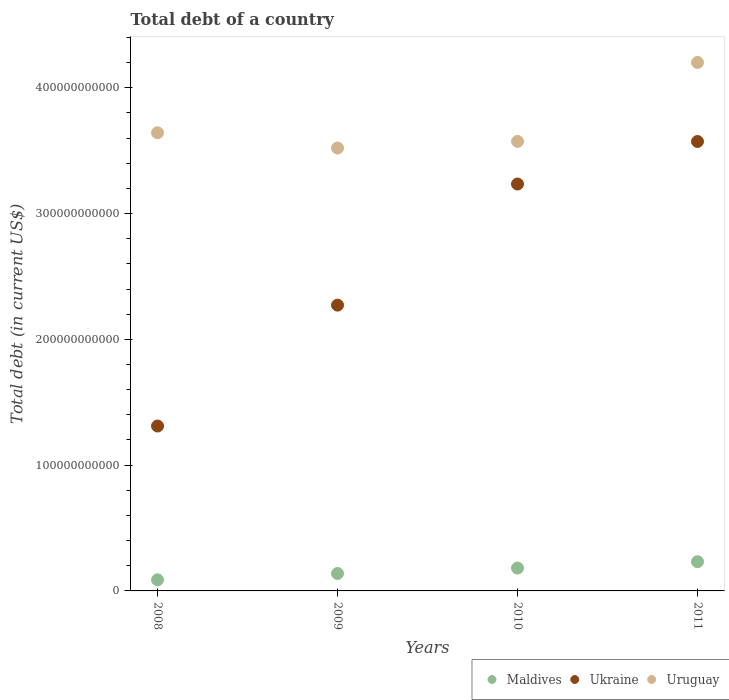How many different coloured dotlines are there?
Offer a very short reply. 3. What is the debt in Uruguay in 2009?
Offer a terse response. 3.52e+11. Across all years, what is the maximum debt in Maldives?
Keep it short and to the point. 2.32e+1. Across all years, what is the minimum debt in Maldives?
Give a very brief answer. 8.82e+09. In which year was the debt in Uruguay maximum?
Make the answer very short. 2011. What is the total debt in Maldives in the graph?
Your answer should be compact. 6.41e+1. What is the difference between the debt in Uruguay in 2009 and that in 2011?
Give a very brief answer. -6.80e+1. What is the difference between the debt in Ukraine in 2008 and the debt in Maldives in 2009?
Your answer should be very brief. 1.17e+11. What is the average debt in Ukraine per year?
Provide a short and direct response. 2.60e+11. In the year 2010, what is the difference between the debt in Ukraine and debt in Maldives?
Your response must be concise. 3.05e+11. What is the ratio of the debt in Maldives in 2008 to that in 2010?
Offer a terse response. 0.49. What is the difference between the highest and the second highest debt in Maldives?
Offer a very short reply. 5.03e+09. What is the difference between the highest and the lowest debt in Maldives?
Make the answer very short. 1.44e+1. In how many years, is the debt in Ukraine greater than the average debt in Ukraine taken over all years?
Keep it short and to the point. 2. Is it the case that in every year, the sum of the debt in Ukraine and debt in Uruguay  is greater than the debt in Maldives?
Your response must be concise. Yes. Does the debt in Uruguay monotonically increase over the years?
Make the answer very short. No. How many dotlines are there?
Your answer should be compact. 3. How many years are there in the graph?
Keep it short and to the point. 4. What is the difference between two consecutive major ticks on the Y-axis?
Offer a very short reply. 1.00e+11. Are the values on the major ticks of Y-axis written in scientific E-notation?
Provide a short and direct response. No. Does the graph contain any zero values?
Offer a very short reply. No. How are the legend labels stacked?
Your answer should be very brief. Horizontal. What is the title of the graph?
Your response must be concise. Total debt of a country. Does "Kiribati" appear as one of the legend labels in the graph?
Offer a terse response. No. What is the label or title of the X-axis?
Give a very brief answer. Years. What is the label or title of the Y-axis?
Your response must be concise. Total debt (in current US$). What is the Total debt (in current US$) of Maldives in 2008?
Provide a short and direct response. 8.82e+09. What is the Total debt (in current US$) in Ukraine in 2008?
Give a very brief answer. 1.31e+11. What is the Total debt (in current US$) in Uruguay in 2008?
Give a very brief answer. 3.64e+11. What is the Total debt (in current US$) of Maldives in 2009?
Your answer should be very brief. 1.39e+1. What is the Total debt (in current US$) of Ukraine in 2009?
Offer a very short reply. 2.27e+11. What is the Total debt (in current US$) in Uruguay in 2009?
Your response must be concise. 3.52e+11. What is the Total debt (in current US$) in Maldives in 2010?
Provide a short and direct response. 1.82e+1. What is the Total debt (in current US$) of Ukraine in 2010?
Your answer should be compact. 3.23e+11. What is the Total debt (in current US$) in Uruguay in 2010?
Keep it short and to the point. 3.57e+11. What is the Total debt (in current US$) in Maldives in 2011?
Provide a succinct answer. 2.32e+1. What is the Total debt (in current US$) in Ukraine in 2011?
Keep it short and to the point. 3.57e+11. What is the Total debt (in current US$) of Uruguay in 2011?
Your answer should be very brief. 4.20e+11. Across all years, what is the maximum Total debt (in current US$) of Maldives?
Provide a short and direct response. 2.32e+1. Across all years, what is the maximum Total debt (in current US$) in Ukraine?
Your response must be concise. 3.57e+11. Across all years, what is the maximum Total debt (in current US$) of Uruguay?
Your answer should be compact. 4.20e+11. Across all years, what is the minimum Total debt (in current US$) in Maldives?
Provide a short and direct response. 8.82e+09. Across all years, what is the minimum Total debt (in current US$) of Ukraine?
Offer a terse response. 1.31e+11. Across all years, what is the minimum Total debt (in current US$) in Uruguay?
Offer a very short reply. 3.52e+11. What is the total Total debt (in current US$) in Maldives in the graph?
Your answer should be compact. 6.41e+1. What is the total Total debt (in current US$) in Ukraine in the graph?
Provide a short and direct response. 1.04e+12. What is the total Total debt (in current US$) in Uruguay in the graph?
Offer a very short reply. 1.49e+12. What is the difference between the Total debt (in current US$) in Maldives in 2008 and that in 2009?
Ensure brevity in your answer.  -5.04e+09. What is the difference between the Total debt (in current US$) in Ukraine in 2008 and that in 2009?
Keep it short and to the point. -9.61e+1. What is the difference between the Total debt (in current US$) in Uruguay in 2008 and that in 2009?
Provide a short and direct response. 1.21e+1. What is the difference between the Total debt (in current US$) of Maldives in 2008 and that in 2010?
Make the answer very short. -9.36e+09. What is the difference between the Total debt (in current US$) of Ukraine in 2008 and that in 2010?
Your answer should be compact. -1.92e+11. What is the difference between the Total debt (in current US$) in Uruguay in 2008 and that in 2010?
Keep it short and to the point. 6.86e+09. What is the difference between the Total debt (in current US$) in Maldives in 2008 and that in 2011?
Make the answer very short. -1.44e+1. What is the difference between the Total debt (in current US$) of Ukraine in 2008 and that in 2011?
Keep it short and to the point. -2.26e+11. What is the difference between the Total debt (in current US$) in Uruguay in 2008 and that in 2011?
Your answer should be very brief. -5.59e+1. What is the difference between the Total debt (in current US$) in Maldives in 2009 and that in 2010?
Give a very brief answer. -4.32e+09. What is the difference between the Total debt (in current US$) of Ukraine in 2009 and that in 2010?
Your answer should be compact. -9.63e+1. What is the difference between the Total debt (in current US$) in Uruguay in 2009 and that in 2010?
Provide a succinct answer. -5.28e+09. What is the difference between the Total debt (in current US$) in Maldives in 2009 and that in 2011?
Provide a short and direct response. -9.34e+09. What is the difference between the Total debt (in current US$) in Ukraine in 2009 and that in 2011?
Provide a short and direct response. -1.30e+11. What is the difference between the Total debt (in current US$) of Uruguay in 2009 and that in 2011?
Your answer should be very brief. -6.80e+1. What is the difference between the Total debt (in current US$) of Maldives in 2010 and that in 2011?
Your answer should be compact. -5.03e+09. What is the difference between the Total debt (in current US$) in Ukraine in 2010 and that in 2011?
Make the answer very short. -3.38e+1. What is the difference between the Total debt (in current US$) in Uruguay in 2010 and that in 2011?
Your answer should be compact. -6.28e+1. What is the difference between the Total debt (in current US$) of Maldives in 2008 and the Total debt (in current US$) of Ukraine in 2009?
Your response must be concise. -2.18e+11. What is the difference between the Total debt (in current US$) in Maldives in 2008 and the Total debt (in current US$) in Uruguay in 2009?
Provide a short and direct response. -3.43e+11. What is the difference between the Total debt (in current US$) of Ukraine in 2008 and the Total debt (in current US$) of Uruguay in 2009?
Offer a very short reply. -2.21e+11. What is the difference between the Total debt (in current US$) in Maldives in 2008 and the Total debt (in current US$) in Ukraine in 2010?
Provide a succinct answer. -3.15e+11. What is the difference between the Total debt (in current US$) in Maldives in 2008 and the Total debt (in current US$) in Uruguay in 2010?
Your answer should be compact. -3.49e+11. What is the difference between the Total debt (in current US$) of Ukraine in 2008 and the Total debt (in current US$) of Uruguay in 2010?
Offer a terse response. -2.26e+11. What is the difference between the Total debt (in current US$) of Maldives in 2008 and the Total debt (in current US$) of Ukraine in 2011?
Your response must be concise. -3.48e+11. What is the difference between the Total debt (in current US$) in Maldives in 2008 and the Total debt (in current US$) in Uruguay in 2011?
Keep it short and to the point. -4.11e+11. What is the difference between the Total debt (in current US$) in Ukraine in 2008 and the Total debt (in current US$) in Uruguay in 2011?
Make the answer very short. -2.89e+11. What is the difference between the Total debt (in current US$) in Maldives in 2009 and the Total debt (in current US$) in Ukraine in 2010?
Make the answer very short. -3.10e+11. What is the difference between the Total debt (in current US$) in Maldives in 2009 and the Total debt (in current US$) in Uruguay in 2010?
Make the answer very short. -3.43e+11. What is the difference between the Total debt (in current US$) of Ukraine in 2009 and the Total debt (in current US$) of Uruguay in 2010?
Offer a terse response. -1.30e+11. What is the difference between the Total debt (in current US$) in Maldives in 2009 and the Total debt (in current US$) in Ukraine in 2011?
Offer a very short reply. -3.43e+11. What is the difference between the Total debt (in current US$) in Maldives in 2009 and the Total debt (in current US$) in Uruguay in 2011?
Offer a very short reply. -4.06e+11. What is the difference between the Total debt (in current US$) of Ukraine in 2009 and the Total debt (in current US$) of Uruguay in 2011?
Your answer should be compact. -1.93e+11. What is the difference between the Total debt (in current US$) of Maldives in 2010 and the Total debt (in current US$) of Ukraine in 2011?
Your answer should be compact. -3.39e+11. What is the difference between the Total debt (in current US$) of Maldives in 2010 and the Total debt (in current US$) of Uruguay in 2011?
Give a very brief answer. -4.02e+11. What is the difference between the Total debt (in current US$) in Ukraine in 2010 and the Total debt (in current US$) in Uruguay in 2011?
Offer a terse response. -9.66e+1. What is the average Total debt (in current US$) of Maldives per year?
Ensure brevity in your answer.  1.60e+1. What is the average Total debt (in current US$) of Ukraine per year?
Offer a very short reply. 2.60e+11. What is the average Total debt (in current US$) of Uruguay per year?
Provide a succinct answer. 3.73e+11. In the year 2008, what is the difference between the Total debt (in current US$) in Maldives and Total debt (in current US$) in Ukraine?
Make the answer very short. -1.22e+11. In the year 2008, what is the difference between the Total debt (in current US$) in Maldives and Total debt (in current US$) in Uruguay?
Provide a succinct answer. -3.55e+11. In the year 2008, what is the difference between the Total debt (in current US$) of Ukraine and Total debt (in current US$) of Uruguay?
Your answer should be very brief. -2.33e+11. In the year 2009, what is the difference between the Total debt (in current US$) in Maldives and Total debt (in current US$) in Ukraine?
Offer a very short reply. -2.13e+11. In the year 2009, what is the difference between the Total debt (in current US$) of Maldives and Total debt (in current US$) of Uruguay?
Provide a short and direct response. -3.38e+11. In the year 2009, what is the difference between the Total debt (in current US$) in Ukraine and Total debt (in current US$) in Uruguay?
Make the answer very short. -1.25e+11. In the year 2010, what is the difference between the Total debt (in current US$) in Maldives and Total debt (in current US$) in Ukraine?
Your response must be concise. -3.05e+11. In the year 2010, what is the difference between the Total debt (in current US$) of Maldives and Total debt (in current US$) of Uruguay?
Give a very brief answer. -3.39e+11. In the year 2010, what is the difference between the Total debt (in current US$) in Ukraine and Total debt (in current US$) in Uruguay?
Make the answer very short. -3.39e+1. In the year 2011, what is the difference between the Total debt (in current US$) of Maldives and Total debt (in current US$) of Ukraine?
Give a very brief answer. -3.34e+11. In the year 2011, what is the difference between the Total debt (in current US$) of Maldives and Total debt (in current US$) of Uruguay?
Ensure brevity in your answer.  -3.97e+11. In the year 2011, what is the difference between the Total debt (in current US$) in Ukraine and Total debt (in current US$) in Uruguay?
Keep it short and to the point. -6.28e+1. What is the ratio of the Total debt (in current US$) of Maldives in 2008 to that in 2009?
Offer a terse response. 0.64. What is the ratio of the Total debt (in current US$) of Ukraine in 2008 to that in 2009?
Offer a terse response. 0.58. What is the ratio of the Total debt (in current US$) of Uruguay in 2008 to that in 2009?
Your answer should be very brief. 1.03. What is the ratio of the Total debt (in current US$) of Maldives in 2008 to that in 2010?
Make the answer very short. 0.49. What is the ratio of the Total debt (in current US$) in Ukraine in 2008 to that in 2010?
Ensure brevity in your answer.  0.41. What is the ratio of the Total debt (in current US$) of Uruguay in 2008 to that in 2010?
Your answer should be compact. 1.02. What is the ratio of the Total debt (in current US$) in Maldives in 2008 to that in 2011?
Your answer should be compact. 0.38. What is the ratio of the Total debt (in current US$) of Ukraine in 2008 to that in 2011?
Your answer should be very brief. 0.37. What is the ratio of the Total debt (in current US$) of Uruguay in 2008 to that in 2011?
Your answer should be compact. 0.87. What is the ratio of the Total debt (in current US$) of Maldives in 2009 to that in 2010?
Ensure brevity in your answer.  0.76. What is the ratio of the Total debt (in current US$) of Ukraine in 2009 to that in 2010?
Provide a short and direct response. 0.7. What is the ratio of the Total debt (in current US$) in Uruguay in 2009 to that in 2010?
Your answer should be very brief. 0.99. What is the ratio of the Total debt (in current US$) of Maldives in 2009 to that in 2011?
Keep it short and to the point. 0.6. What is the ratio of the Total debt (in current US$) of Ukraine in 2009 to that in 2011?
Give a very brief answer. 0.64. What is the ratio of the Total debt (in current US$) in Uruguay in 2009 to that in 2011?
Keep it short and to the point. 0.84. What is the ratio of the Total debt (in current US$) in Maldives in 2010 to that in 2011?
Offer a terse response. 0.78. What is the ratio of the Total debt (in current US$) in Ukraine in 2010 to that in 2011?
Give a very brief answer. 0.91. What is the ratio of the Total debt (in current US$) in Uruguay in 2010 to that in 2011?
Your answer should be compact. 0.85. What is the difference between the highest and the second highest Total debt (in current US$) of Maldives?
Your response must be concise. 5.03e+09. What is the difference between the highest and the second highest Total debt (in current US$) of Ukraine?
Offer a very short reply. 3.38e+1. What is the difference between the highest and the second highest Total debt (in current US$) of Uruguay?
Ensure brevity in your answer.  5.59e+1. What is the difference between the highest and the lowest Total debt (in current US$) in Maldives?
Your answer should be compact. 1.44e+1. What is the difference between the highest and the lowest Total debt (in current US$) in Ukraine?
Your response must be concise. 2.26e+11. What is the difference between the highest and the lowest Total debt (in current US$) of Uruguay?
Your answer should be very brief. 6.80e+1. 